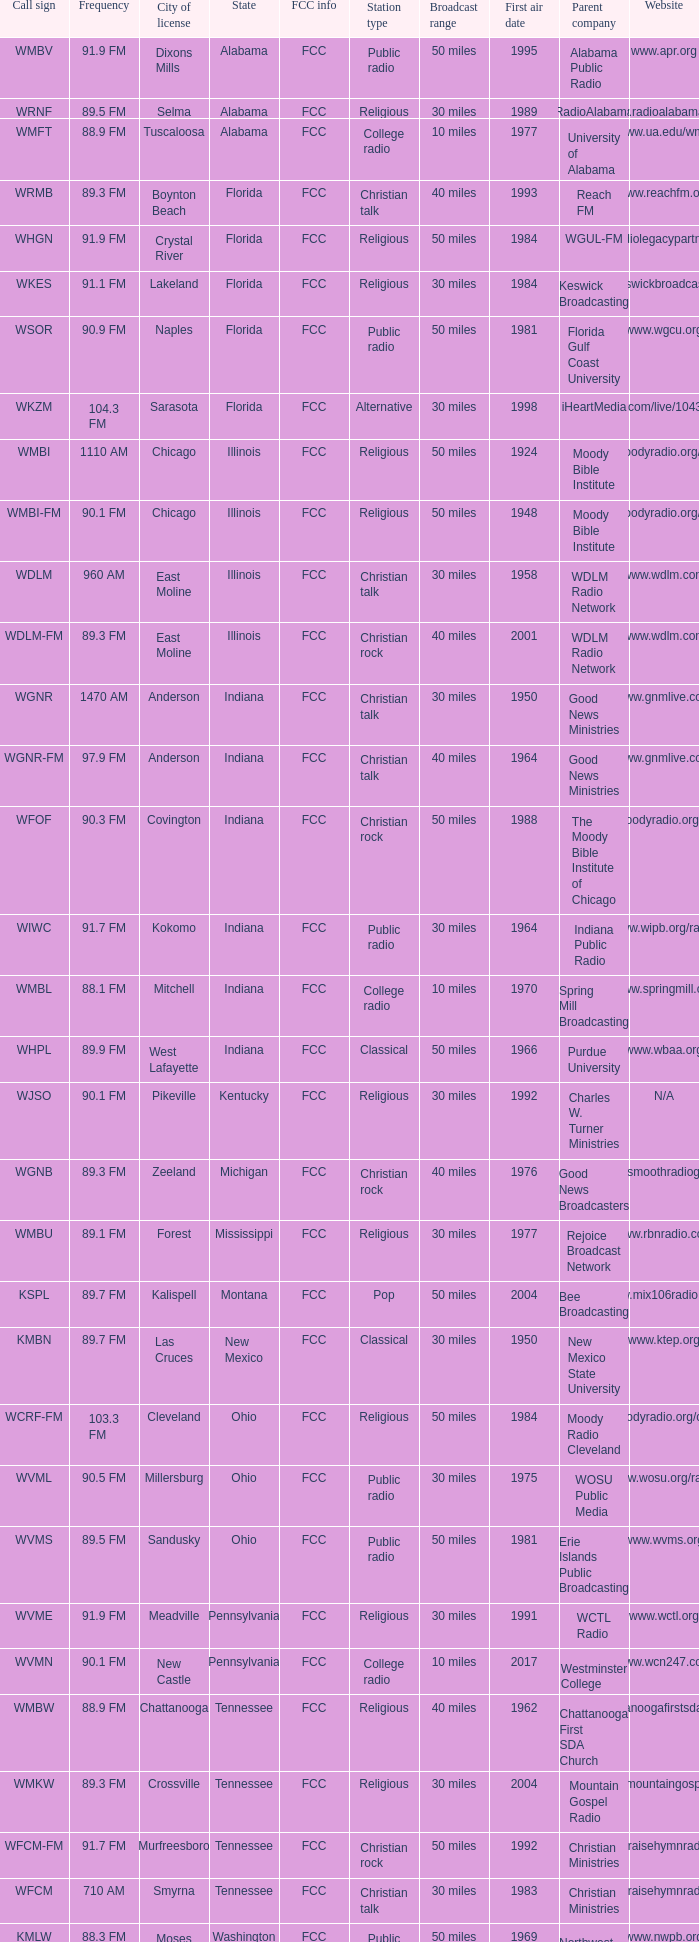In what state can you find the radio station that has a 9 Pennsylvania. 